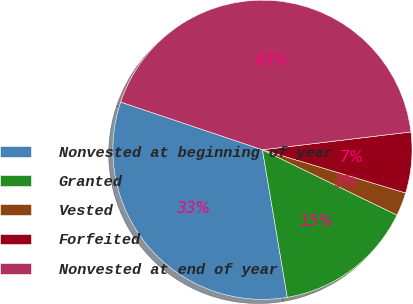Convert chart. <chart><loc_0><loc_0><loc_500><loc_500><pie_chart><fcel>Nonvested at beginning of year<fcel>Granted<fcel>Vested<fcel>Forfeited<fcel>Nonvested at end of year<nl><fcel>32.83%<fcel>15.15%<fcel>2.53%<fcel>6.57%<fcel>42.93%<nl></chart> 